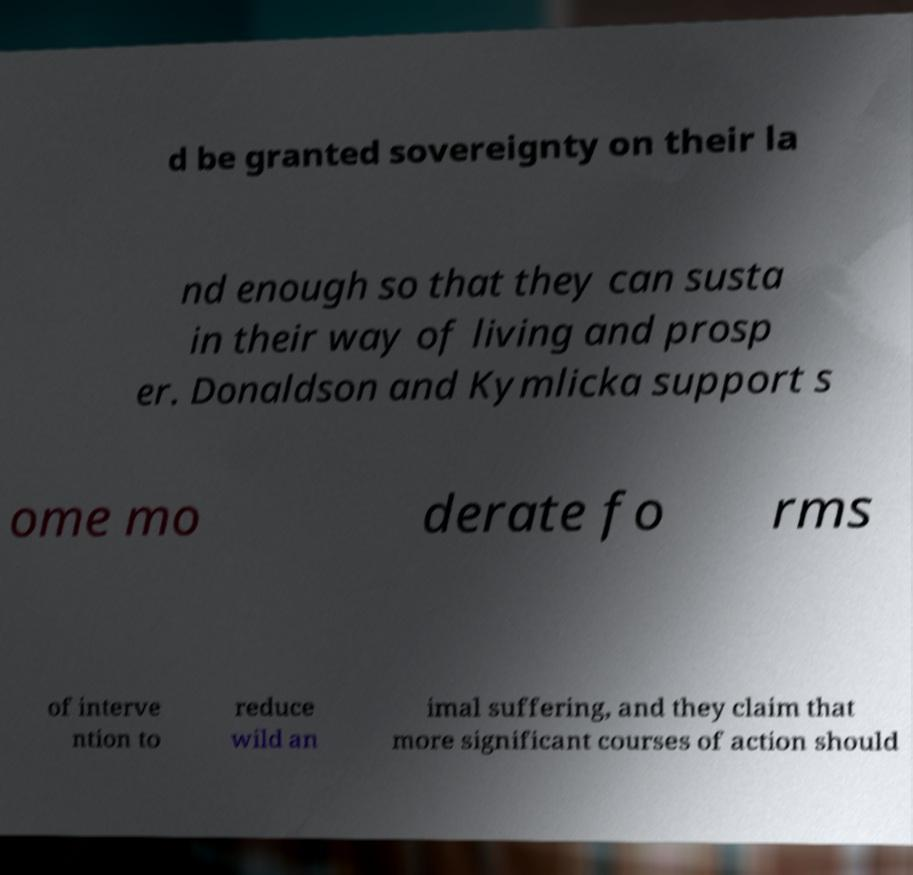Can you read and provide the text displayed in the image?This photo seems to have some interesting text. Can you extract and type it out for me? d be granted sovereignty on their la nd enough so that they can susta in their way of living and prosp er. Donaldson and Kymlicka support s ome mo derate fo rms of interve ntion to reduce wild an imal suffering, and they claim that more significant courses of action should 